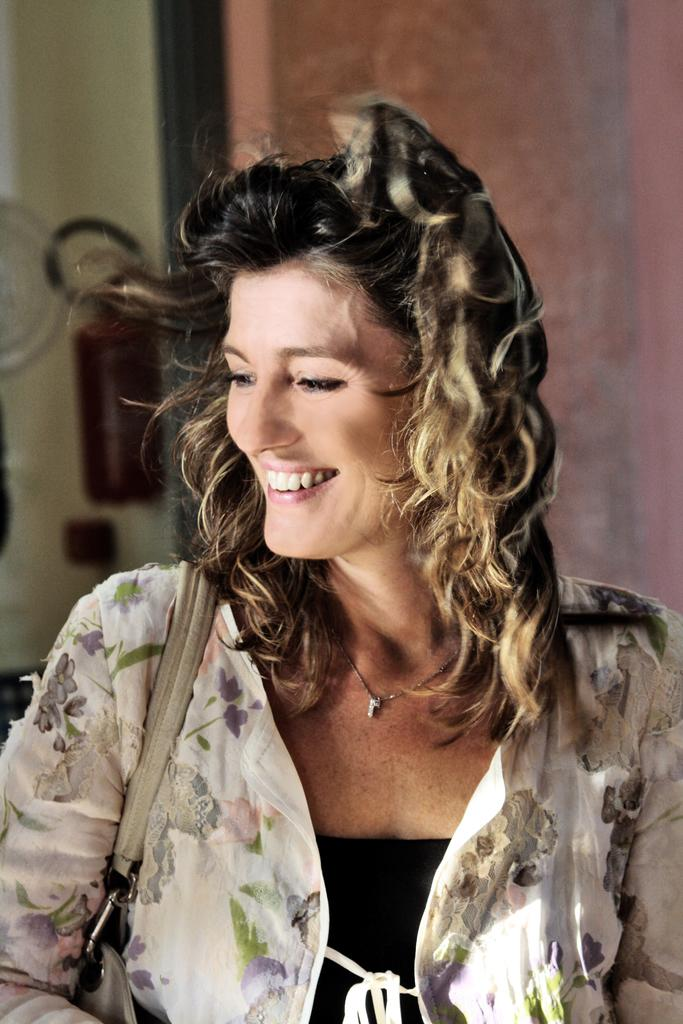Who is the main subject in the image? There is a woman in the picture. Where is the woman located in the image? The woman is in the middle of the image. What expression does the woman have? The woman is smiling. What is the woman wearing in the image? The woman is wearing a dress. What type of border is present around the woman in the image? There is no border present around the woman in the image. What is the value of the cent in the image? There is no cent present in the image. 